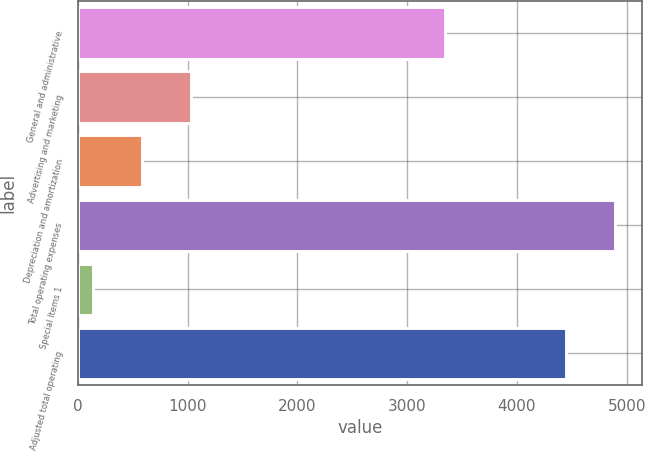Convert chart to OTSL. <chart><loc_0><loc_0><loc_500><loc_500><bar_chart><fcel>General and administrative<fcel>Advertising and marketing<fcel>Depreciation and amortization<fcel>Total operating expenses<fcel>Special Items 1<fcel>Adjusted total operating<nl><fcel>3341<fcel>1029.8<fcel>584.9<fcel>4893.9<fcel>140<fcel>4449<nl></chart> 